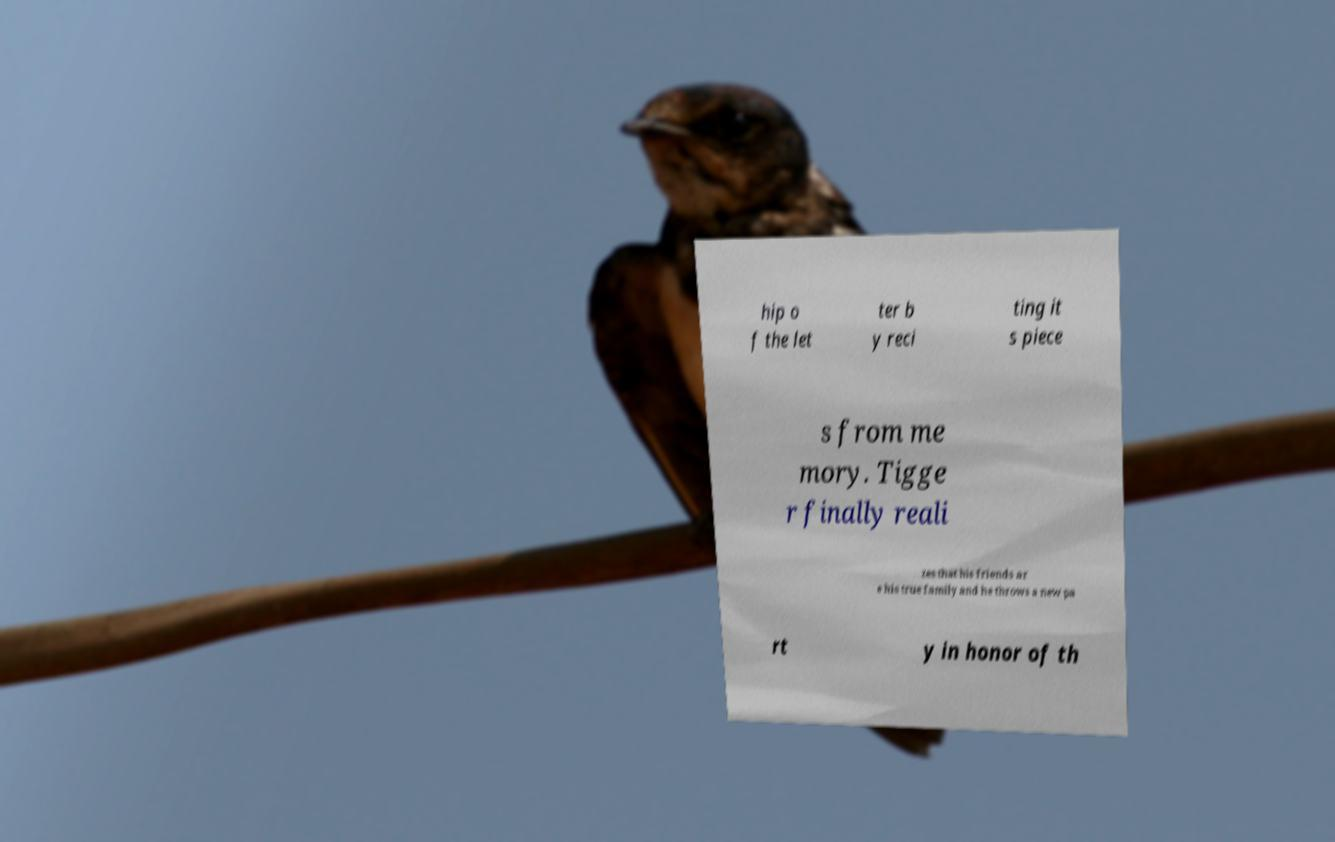Please read and relay the text visible in this image. What does it say? hip o f the let ter b y reci ting it s piece s from me mory. Tigge r finally reali zes that his friends ar e his true family and he throws a new pa rt y in honor of th 